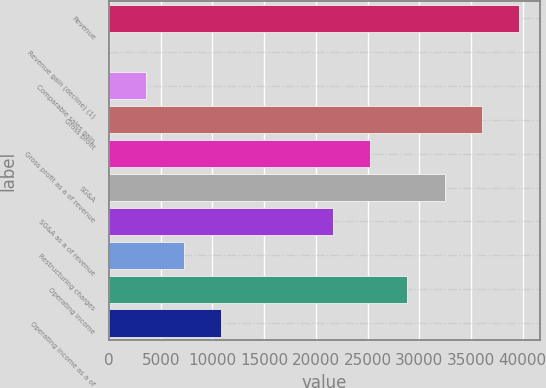Convert chart to OTSL. <chart><loc_0><loc_0><loc_500><loc_500><bar_chart><fcel>Revenue<fcel>Revenue gain (decline) (1)<fcel>Comparable sales gain<fcel>Gross profit<fcel>Gross profit as a of revenue<fcel>SG&A<fcel>SG&A as a of revenue<fcel>Restructuring charges<fcel>Operating income<fcel>Operating income as a of<nl><fcel>39660.4<fcel>0.6<fcel>3606.04<fcel>36055<fcel>25238.7<fcel>32449.6<fcel>21633.2<fcel>7211.48<fcel>28844.1<fcel>10816.9<nl></chart> 